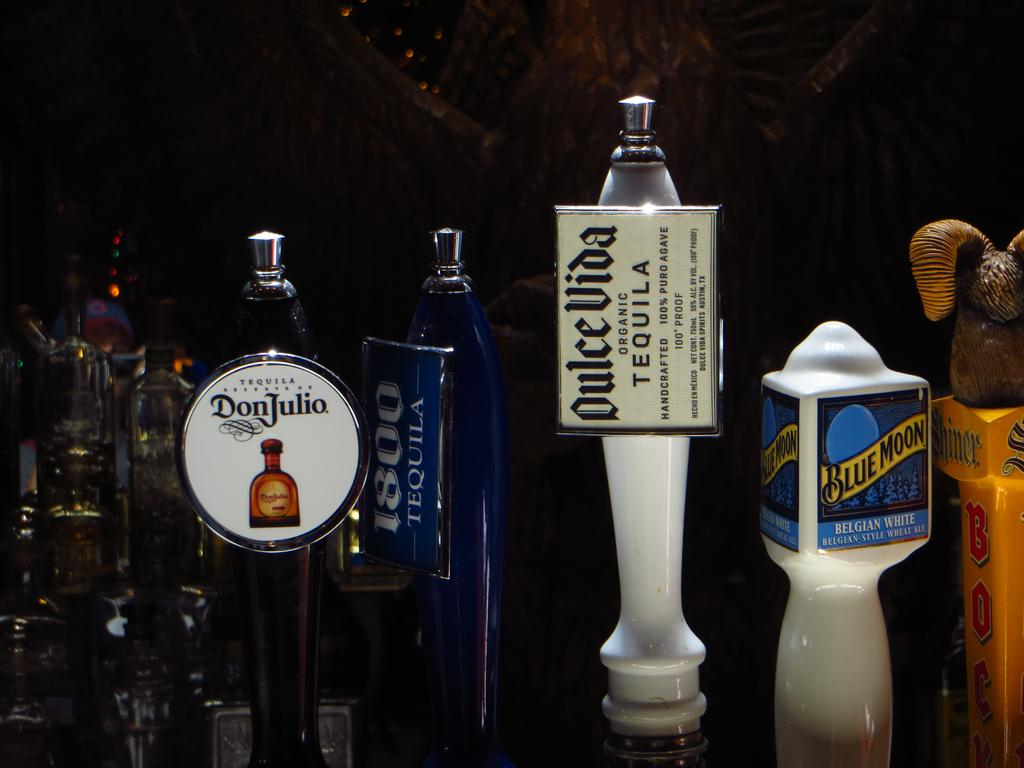<image>
Share a concise interpretation of the image provided. Several bottles of alcohol are arranged with one bearing the logo for Don Julio in a circular label. 